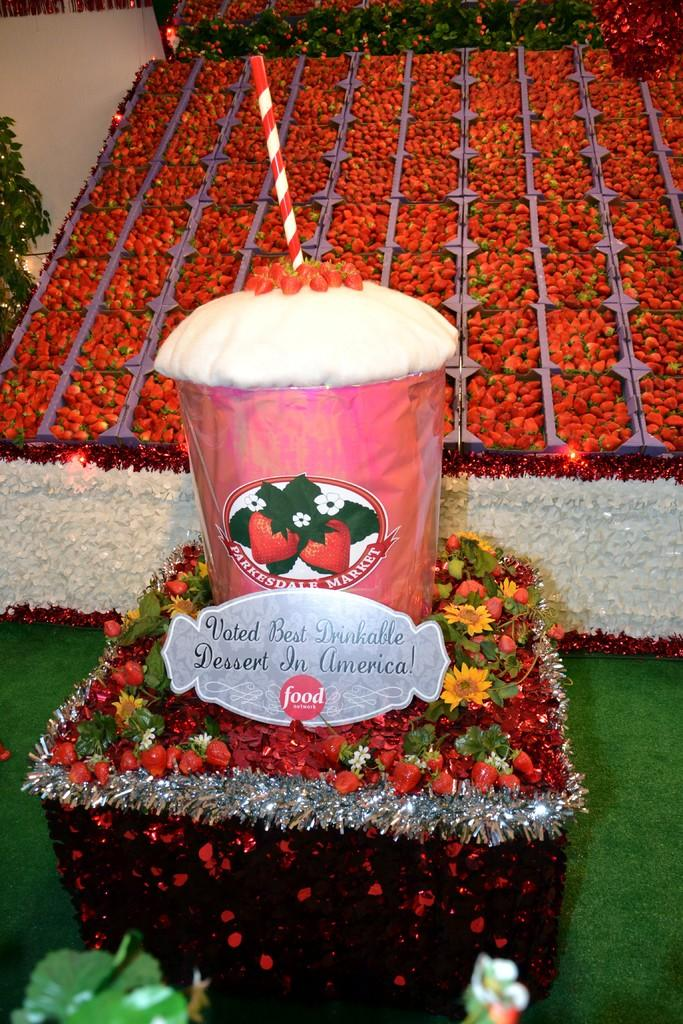What type of food is featured in the image? There is a dessert in the image. What other elements can be seen in the image besides the dessert? There are flowers and a plant visible in the image. What can be seen in the background of the image? Fruits are visible in the background of the image. What is on the floor at the bottom of the image? There is a green mat on the floor at the bottom of the image. What type of string is being used to play the instrument on the stage in the image? There is no instrument or stage present in the image; it features a dessert, flowers, fruits, a plant, and a green mat. 